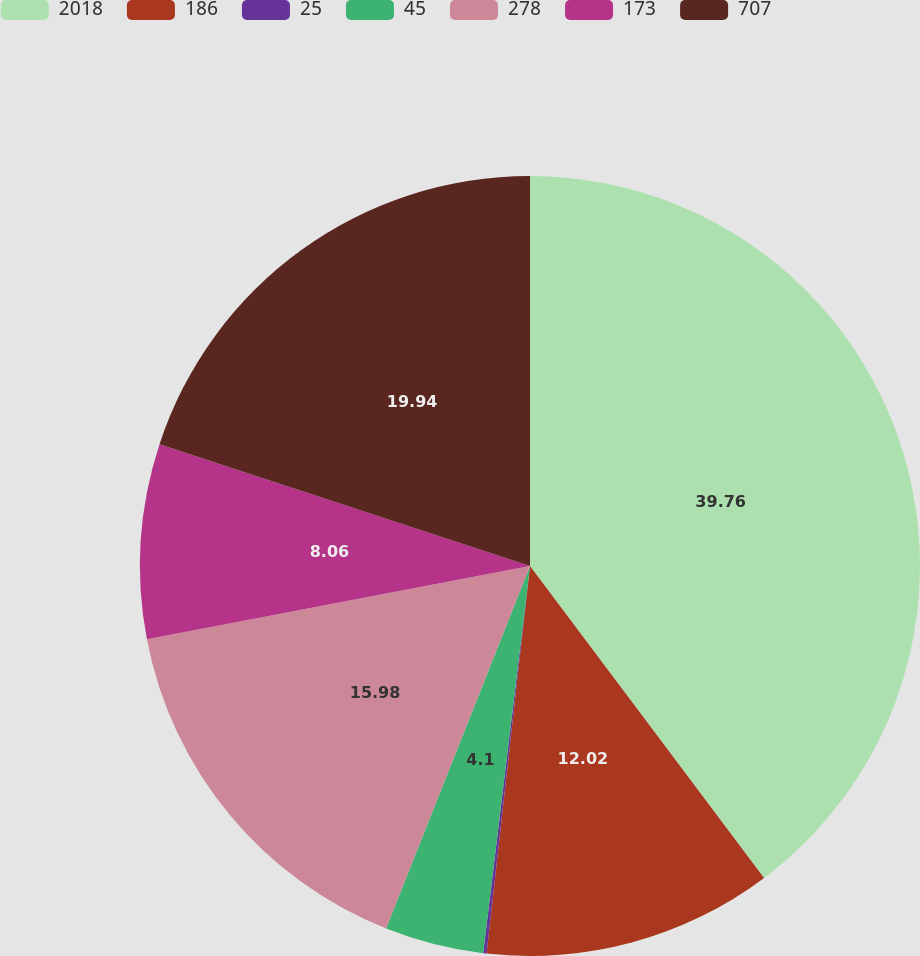Convert chart to OTSL. <chart><loc_0><loc_0><loc_500><loc_500><pie_chart><fcel>2018<fcel>186<fcel>25<fcel>45<fcel>278<fcel>173<fcel>707<nl><fcel>39.75%<fcel>12.02%<fcel>0.14%<fcel>4.1%<fcel>15.98%<fcel>8.06%<fcel>19.94%<nl></chart> 